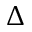Convert formula to latex. <formula><loc_0><loc_0><loc_500><loc_500>\Delta</formula> 